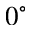Convert formula to latex. <formula><loc_0><loc_0><loc_500><loc_500>0 ^ { \circ }</formula> 